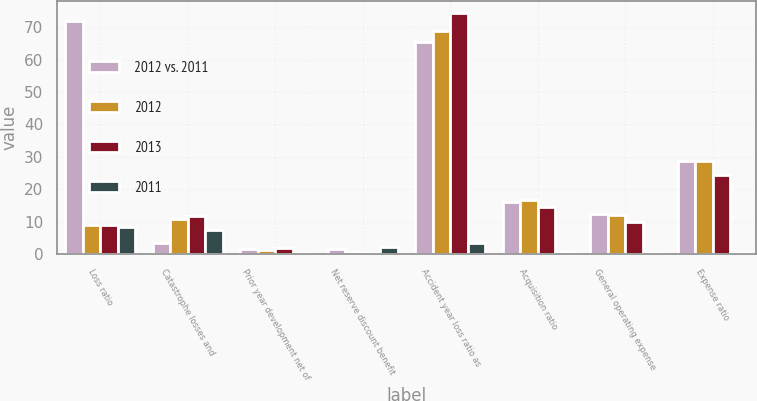Convert chart to OTSL. <chart><loc_0><loc_0><loc_500><loc_500><stacked_bar_chart><ecel><fcel>Loss ratio<fcel>Catastrophe losses and<fcel>Prior year development net of<fcel>Net reserve discount benefit<fcel>Accident year loss ratio as<fcel>Acquisition ratio<fcel>General operating expense<fcel>Expense ratio<nl><fcel>2012 vs. 2011<fcel>71.9<fcel>3.5<fcel>1.5<fcel>1.6<fcel>65.3<fcel>16.1<fcel>12.5<fcel>28.6<nl><fcel>2012<fcel>9.1<fcel>10.9<fcel>1.2<fcel>0.5<fcel>68.7<fcel>16.6<fcel>12.2<fcel>28.8<nl><fcel>2013<fcel>9.1<fcel>11.9<fcel>1.9<fcel>0.2<fcel>74.3<fcel>14.6<fcel>9.8<fcel>24.4<nl><fcel>2011<fcel>8.4<fcel>7.4<fcel>0.3<fcel>2.1<fcel>3.4<fcel>0.5<fcel>0.3<fcel>0.2<nl></chart> 